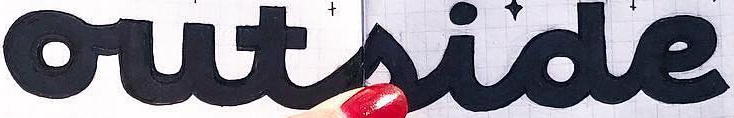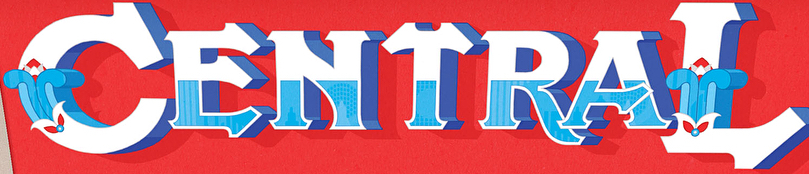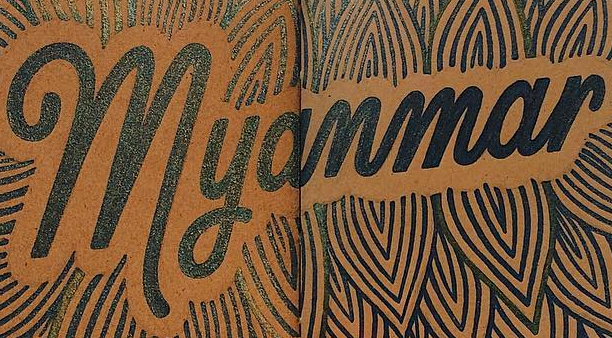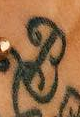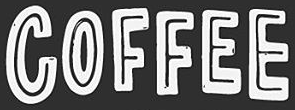What text is displayed in these images sequentially, separated by a semicolon? outside; CENTRAL; Myanmar; B; COFFEE 